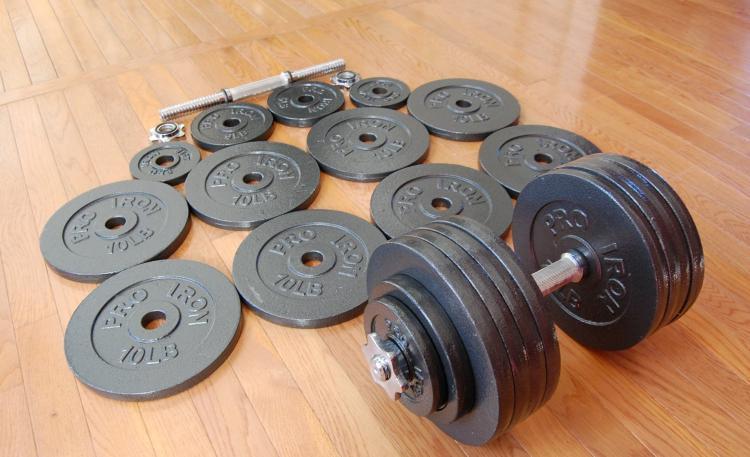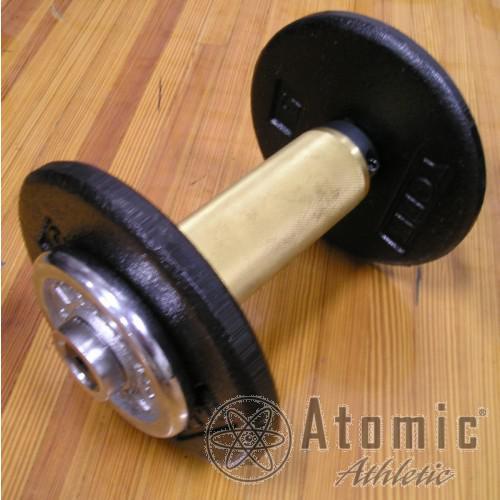The first image is the image on the left, the second image is the image on the right. Considering the images on both sides, is "there is a dumb bell laying on a wood floor next to 12 seperate circular flat weights" valid? Answer yes or no. Yes. The first image is the image on the left, the second image is the image on the right. Considering the images on both sides, is "One of the images shows an assembled dumbbell with additional plates next to it." valid? Answer yes or no. Yes. 